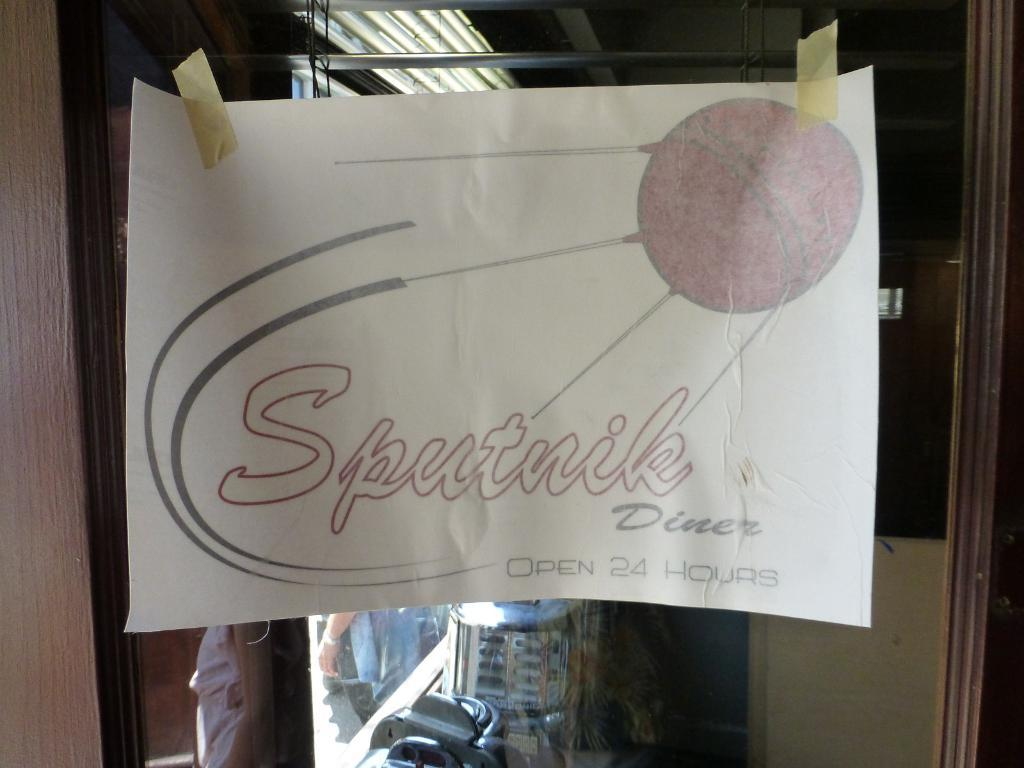What is written on the paper in the foreground of the image? The word "Sputnik" is written on the paper in the foreground of the image. How is the paper positioned in the image? The paper is stuck to a glass. What can be seen in the background of the image? There are persons and a wall in the background of the image. What does the head of the person in the image taste like? There is no mention of a person's head in the image, so it is not possible to determine its taste. 